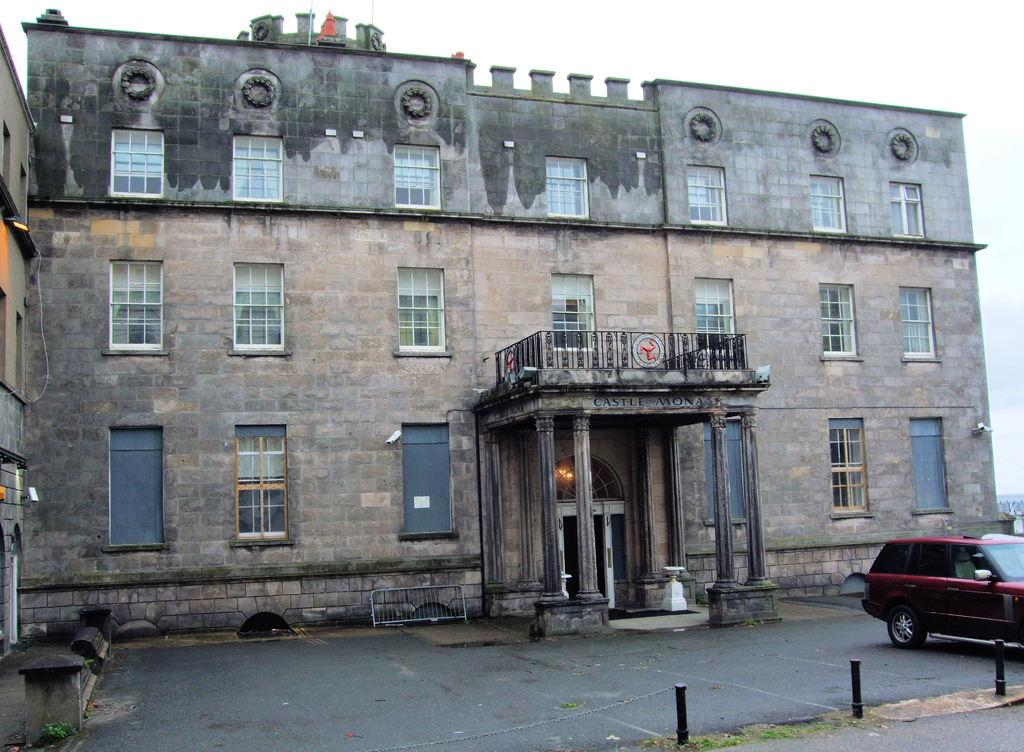What is the main subject in the center of the image? There is a building in the center of the image. What feature can be seen on the building? The building has windows. What type of vehicle is on the right side of the image? There is a red car on the right side of the image. What type of stew is being cooked in the building in the image? There is no indication of any cooking or stew in the image; it only features a building and a red car. 